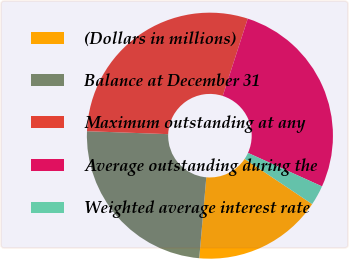Convert chart to OTSL. <chart><loc_0><loc_0><loc_500><loc_500><pie_chart><fcel>(Dollars in millions)<fcel>Balance at December 31<fcel>Maximum outstanding at any<fcel>Average outstanding during the<fcel>Weighted average interest rate<nl><fcel>17.0%<fcel>24.2%<fcel>29.39%<fcel>26.79%<fcel>2.62%<nl></chart> 